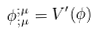<formula> <loc_0><loc_0><loc_500><loc_500>\phi _ { ; \mu } ^ { ; \mu } = V ^ { \prime } ( \phi )</formula> 